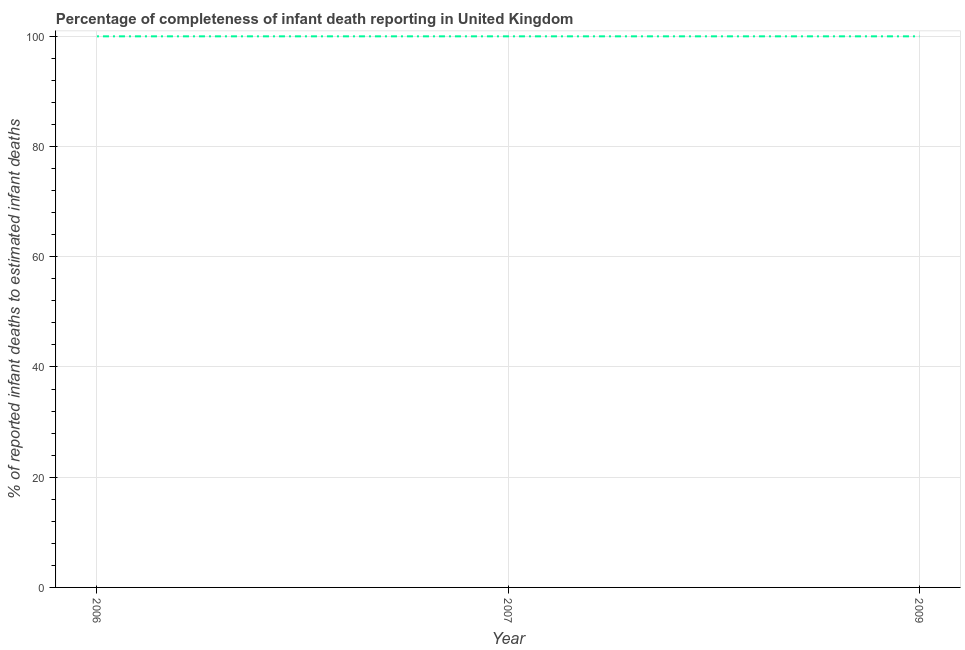What is the completeness of infant death reporting in 2009?
Offer a very short reply. 100. Across all years, what is the maximum completeness of infant death reporting?
Provide a succinct answer. 100. Across all years, what is the minimum completeness of infant death reporting?
Keep it short and to the point. 100. What is the sum of the completeness of infant death reporting?
Offer a very short reply. 300. What is the difference between the completeness of infant death reporting in 2006 and 2009?
Your answer should be very brief. 0. What is the average completeness of infant death reporting per year?
Keep it short and to the point. 100. What is the median completeness of infant death reporting?
Your answer should be compact. 100. In how many years, is the completeness of infant death reporting greater than 76 %?
Offer a very short reply. 3. What is the ratio of the completeness of infant death reporting in 2006 to that in 2009?
Offer a terse response. 1. Is the completeness of infant death reporting in 2006 less than that in 2009?
Provide a succinct answer. No. What is the difference between the highest and the second highest completeness of infant death reporting?
Your response must be concise. 0. Is the sum of the completeness of infant death reporting in 2006 and 2009 greater than the maximum completeness of infant death reporting across all years?
Your answer should be compact. Yes. How many lines are there?
Your answer should be very brief. 1. Does the graph contain any zero values?
Give a very brief answer. No. Does the graph contain grids?
Provide a short and direct response. Yes. What is the title of the graph?
Your answer should be compact. Percentage of completeness of infant death reporting in United Kingdom. What is the label or title of the X-axis?
Your response must be concise. Year. What is the label or title of the Y-axis?
Ensure brevity in your answer.  % of reported infant deaths to estimated infant deaths. What is the % of reported infant deaths to estimated infant deaths of 2006?
Your answer should be compact. 100. What is the % of reported infant deaths to estimated infant deaths of 2007?
Your response must be concise. 100. What is the difference between the % of reported infant deaths to estimated infant deaths in 2007 and 2009?
Offer a very short reply. 0. 